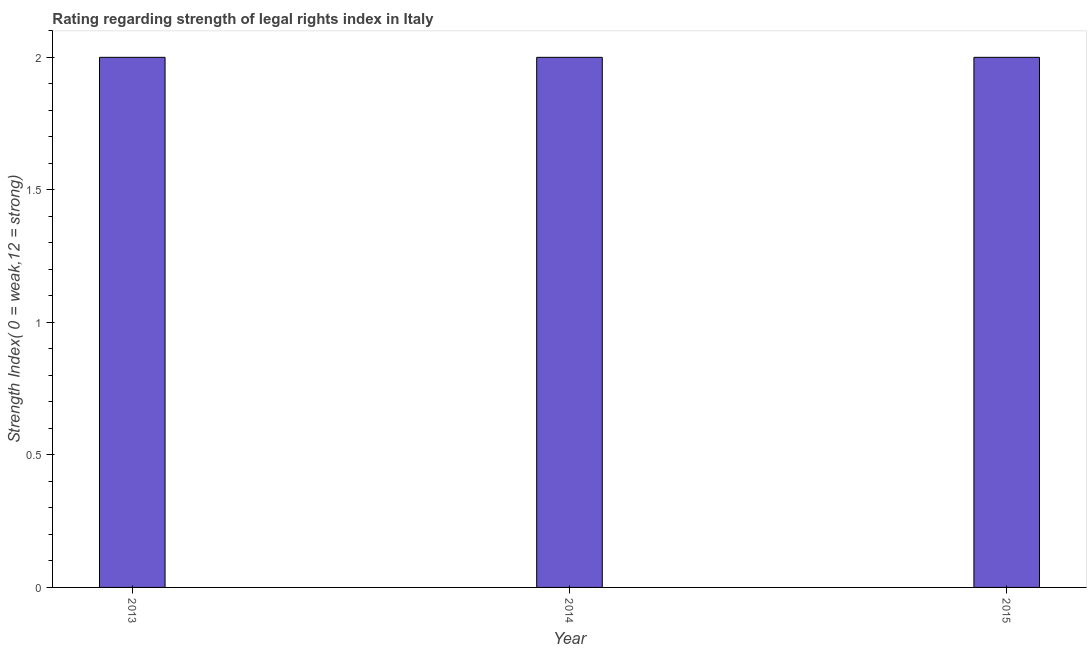Does the graph contain any zero values?
Keep it short and to the point. No. What is the title of the graph?
Provide a succinct answer. Rating regarding strength of legal rights index in Italy. What is the label or title of the Y-axis?
Give a very brief answer. Strength Index( 0 = weak,12 = strong). Across all years, what is the maximum strength of legal rights index?
Your response must be concise. 2. What is the sum of the strength of legal rights index?
Ensure brevity in your answer.  6. What is the median strength of legal rights index?
Ensure brevity in your answer.  2. Is the strength of legal rights index in 2013 less than that in 2014?
Your response must be concise. No. Is the difference between the strength of legal rights index in 2014 and 2015 greater than the difference between any two years?
Give a very brief answer. Yes. In how many years, is the strength of legal rights index greater than the average strength of legal rights index taken over all years?
Ensure brevity in your answer.  0. How many bars are there?
Your answer should be compact. 3. Are the values on the major ticks of Y-axis written in scientific E-notation?
Make the answer very short. No. What is the Strength Index( 0 = weak,12 = strong) in 2013?
Offer a terse response. 2. What is the Strength Index( 0 = weak,12 = strong) of 2014?
Offer a terse response. 2. What is the Strength Index( 0 = weak,12 = strong) of 2015?
Ensure brevity in your answer.  2. What is the difference between the Strength Index( 0 = weak,12 = strong) in 2013 and 2014?
Offer a terse response. 0. What is the difference between the Strength Index( 0 = weak,12 = strong) in 2013 and 2015?
Provide a short and direct response. 0. What is the ratio of the Strength Index( 0 = weak,12 = strong) in 2013 to that in 2015?
Make the answer very short. 1. 